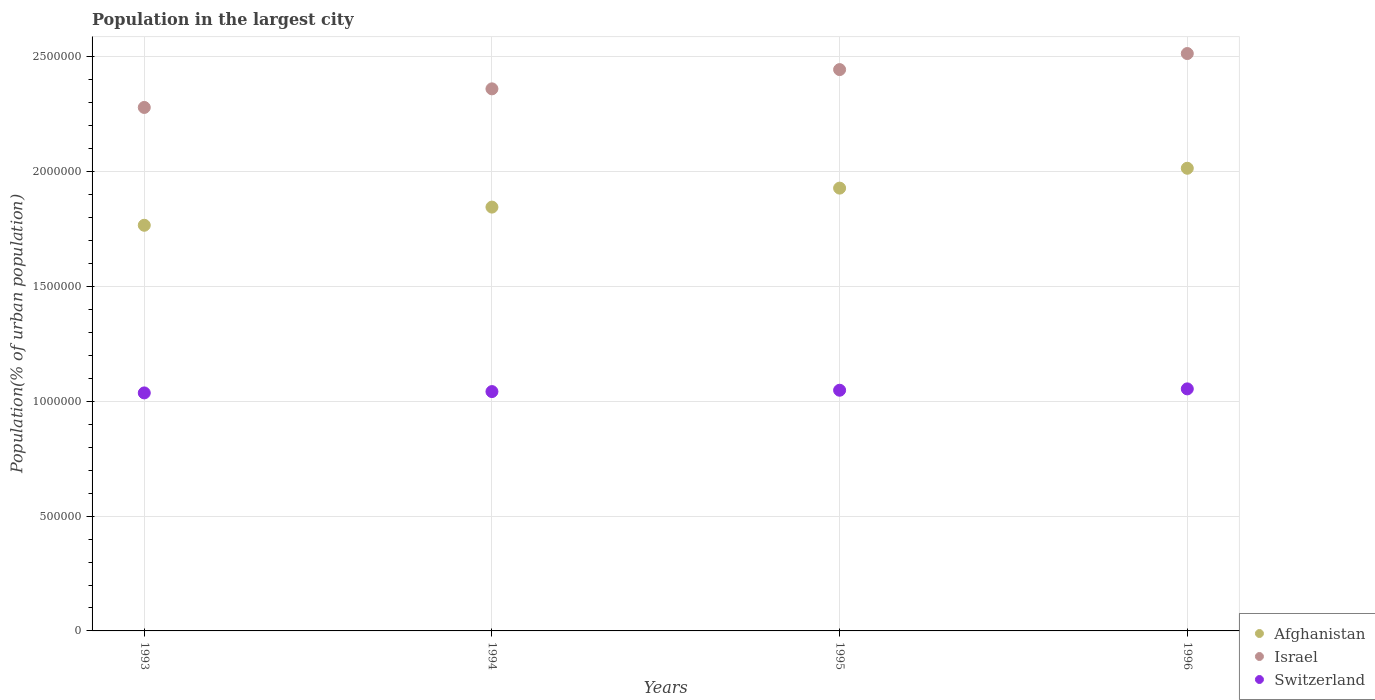Is the number of dotlines equal to the number of legend labels?
Offer a terse response. Yes. What is the population in the largest city in Switzerland in 1994?
Give a very brief answer. 1.04e+06. Across all years, what is the maximum population in the largest city in Afghanistan?
Provide a short and direct response. 2.02e+06. Across all years, what is the minimum population in the largest city in Afghanistan?
Make the answer very short. 1.77e+06. What is the total population in the largest city in Israel in the graph?
Ensure brevity in your answer.  9.60e+06. What is the difference between the population in the largest city in Switzerland in 1995 and that in 1996?
Provide a short and direct response. -5895. What is the difference between the population in the largest city in Switzerland in 1993 and the population in the largest city in Afghanistan in 1996?
Offer a very short reply. -9.78e+05. What is the average population in the largest city in Switzerland per year?
Keep it short and to the point. 1.05e+06. In the year 1993, what is the difference between the population in the largest city in Afghanistan and population in the largest city in Switzerland?
Make the answer very short. 7.30e+05. In how many years, is the population in the largest city in Israel greater than 500000 %?
Make the answer very short. 4. What is the ratio of the population in the largest city in Israel in 1994 to that in 1996?
Your response must be concise. 0.94. Is the difference between the population in the largest city in Afghanistan in 1994 and 1995 greater than the difference between the population in the largest city in Switzerland in 1994 and 1995?
Ensure brevity in your answer.  No. What is the difference between the highest and the second highest population in the largest city in Israel?
Offer a terse response. 6.99e+04. What is the difference between the highest and the lowest population in the largest city in Afghanistan?
Your response must be concise. 2.48e+05. In how many years, is the population in the largest city in Switzerland greater than the average population in the largest city in Switzerland taken over all years?
Offer a terse response. 2. Is the sum of the population in the largest city in Israel in 1993 and 1994 greater than the maximum population in the largest city in Switzerland across all years?
Keep it short and to the point. Yes. Is it the case that in every year, the sum of the population in the largest city in Afghanistan and population in the largest city in Switzerland  is greater than the population in the largest city in Israel?
Ensure brevity in your answer.  Yes. Does the population in the largest city in Switzerland monotonically increase over the years?
Your answer should be compact. Yes. Is the population in the largest city in Switzerland strictly greater than the population in the largest city in Afghanistan over the years?
Your response must be concise. No. Is the population in the largest city in Afghanistan strictly less than the population in the largest city in Israel over the years?
Provide a short and direct response. Yes. How many years are there in the graph?
Provide a short and direct response. 4. Does the graph contain grids?
Provide a succinct answer. Yes. Where does the legend appear in the graph?
Make the answer very short. Bottom right. How many legend labels are there?
Make the answer very short. 3. What is the title of the graph?
Provide a succinct answer. Population in the largest city. Does "Paraguay" appear as one of the legend labels in the graph?
Your response must be concise. No. What is the label or title of the Y-axis?
Your answer should be compact. Population(% of urban population). What is the Population(% of urban population) of Afghanistan in 1993?
Keep it short and to the point. 1.77e+06. What is the Population(% of urban population) in Israel in 1993?
Keep it short and to the point. 2.28e+06. What is the Population(% of urban population) in Switzerland in 1993?
Provide a succinct answer. 1.04e+06. What is the Population(% of urban population) in Afghanistan in 1994?
Your answer should be compact. 1.85e+06. What is the Population(% of urban population) of Israel in 1994?
Provide a succinct answer. 2.36e+06. What is the Population(% of urban population) of Switzerland in 1994?
Provide a succinct answer. 1.04e+06. What is the Population(% of urban population) in Afghanistan in 1995?
Give a very brief answer. 1.93e+06. What is the Population(% of urban population) of Israel in 1995?
Your answer should be compact. 2.44e+06. What is the Population(% of urban population) of Switzerland in 1995?
Your response must be concise. 1.05e+06. What is the Population(% of urban population) of Afghanistan in 1996?
Your answer should be very brief. 2.02e+06. What is the Population(% of urban population) of Israel in 1996?
Give a very brief answer. 2.51e+06. What is the Population(% of urban population) of Switzerland in 1996?
Your answer should be very brief. 1.05e+06. Across all years, what is the maximum Population(% of urban population) of Afghanistan?
Your answer should be very brief. 2.02e+06. Across all years, what is the maximum Population(% of urban population) in Israel?
Offer a terse response. 2.51e+06. Across all years, what is the maximum Population(% of urban population) of Switzerland?
Your response must be concise. 1.05e+06. Across all years, what is the minimum Population(% of urban population) in Afghanistan?
Make the answer very short. 1.77e+06. Across all years, what is the minimum Population(% of urban population) of Israel?
Keep it short and to the point. 2.28e+06. Across all years, what is the minimum Population(% of urban population) in Switzerland?
Offer a very short reply. 1.04e+06. What is the total Population(% of urban population) of Afghanistan in the graph?
Provide a short and direct response. 7.56e+06. What is the total Population(% of urban population) in Israel in the graph?
Provide a short and direct response. 9.60e+06. What is the total Population(% of urban population) of Switzerland in the graph?
Ensure brevity in your answer.  4.18e+06. What is the difference between the Population(% of urban population) of Afghanistan in 1993 and that in 1994?
Offer a terse response. -7.91e+04. What is the difference between the Population(% of urban population) of Israel in 1993 and that in 1994?
Provide a short and direct response. -8.10e+04. What is the difference between the Population(% of urban population) of Switzerland in 1993 and that in 1994?
Ensure brevity in your answer.  -5821. What is the difference between the Population(% of urban population) of Afghanistan in 1993 and that in 1995?
Your response must be concise. -1.62e+05. What is the difference between the Population(% of urban population) in Israel in 1993 and that in 1995?
Give a very brief answer. -1.65e+05. What is the difference between the Population(% of urban population) of Switzerland in 1993 and that in 1995?
Provide a short and direct response. -1.17e+04. What is the difference between the Population(% of urban population) in Afghanistan in 1993 and that in 1996?
Ensure brevity in your answer.  -2.48e+05. What is the difference between the Population(% of urban population) of Israel in 1993 and that in 1996?
Your answer should be very brief. -2.35e+05. What is the difference between the Population(% of urban population) in Switzerland in 1993 and that in 1996?
Provide a succinct answer. -1.76e+04. What is the difference between the Population(% of urban population) in Afghanistan in 1994 and that in 1995?
Ensure brevity in your answer.  -8.27e+04. What is the difference between the Population(% of urban population) of Israel in 1994 and that in 1995?
Provide a short and direct response. -8.39e+04. What is the difference between the Population(% of urban population) of Switzerland in 1994 and that in 1995?
Provide a succinct answer. -5854. What is the difference between the Population(% of urban population) of Afghanistan in 1994 and that in 1996?
Offer a very short reply. -1.69e+05. What is the difference between the Population(% of urban population) of Israel in 1994 and that in 1996?
Your response must be concise. -1.54e+05. What is the difference between the Population(% of urban population) in Switzerland in 1994 and that in 1996?
Your response must be concise. -1.17e+04. What is the difference between the Population(% of urban population) of Afghanistan in 1995 and that in 1996?
Offer a terse response. -8.65e+04. What is the difference between the Population(% of urban population) in Israel in 1995 and that in 1996?
Your answer should be very brief. -6.99e+04. What is the difference between the Population(% of urban population) of Switzerland in 1995 and that in 1996?
Give a very brief answer. -5895. What is the difference between the Population(% of urban population) of Afghanistan in 1993 and the Population(% of urban population) of Israel in 1994?
Make the answer very short. -5.94e+05. What is the difference between the Population(% of urban population) in Afghanistan in 1993 and the Population(% of urban population) in Switzerland in 1994?
Your response must be concise. 7.24e+05. What is the difference between the Population(% of urban population) of Israel in 1993 and the Population(% of urban population) of Switzerland in 1994?
Offer a very short reply. 1.24e+06. What is the difference between the Population(% of urban population) in Afghanistan in 1993 and the Population(% of urban population) in Israel in 1995?
Keep it short and to the point. -6.78e+05. What is the difference between the Population(% of urban population) of Afghanistan in 1993 and the Population(% of urban population) of Switzerland in 1995?
Offer a terse response. 7.19e+05. What is the difference between the Population(% of urban population) in Israel in 1993 and the Population(% of urban population) in Switzerland in 1995?
Give a very brief answer. 1.23e+06. What is the difference between the Population(% of urban population) in Afghanistan in 1993 and the Population(% of urban population) in Israel in 1996?
Your response must be concise. -7.48e+05. What is the difference between the Population(% of urban population) of Afghanistan in 1993 and the Population(% of urban population) of Switzerland in 1996?
Provide a short and direct response. 7.13e+05. What is the difference between the Population(% of urban population) in Israel in 1993 and the Population(% of urban population) in Switzerland in 1996?
Offer a very short reply. 1.23e+06. What is the difference between the Population(% of urban population) in Afghanistan in 1994 and the Population(% of urban population) in Israel in 1995?
Keep it short and to the point. -5.99e+05. What is the difference between the Population(% of urban population) of Afghanistan in 1994 and the Population(% of urban population) of Switzerland in 1995?
Give a very brief answer. 7.98e+05. What is the difference between the Population(% of urban population) of Israel in 1994 and the Population(% of urban population) of Switzerland in 1995?
Provide a succinct answer. 1.31e+06. What is the difference between the Population(% of urban population) in Afghanistan in 1994 and the Population(% of urban population) in Israel in 1996?
Give a very brief answer. -6.69e+05. What is the difference between the Population(% of urban population) in Afghanistan in 1994 and the Population(% of urban population) in Switzerland in 1996?
Give a very brief answer. 7.92e+05. What is the difference between the Population(% of urban population) of Israel in 1994 and the Population(% of urban population) of Switzerland in 1996?
Offer a very short reply. 1.31e+06. What is the difference between the Population(% of urban population) in Afghanistan in 1995 and the Population(% of urban population) in Israel in 1996?
Your answer should be very brief. -5.86e+05. What is the difference between the Population(% of urban population) of Afghanistan in 1995 and the Population(% of urban population) of Switzerland in 1996?
Provide a short and direct response. 8.74e+05. What is the difference between the Population(% of urban population) of Israel in 1995 and the Population(% of urban population) of Switzerland in 1996?
Provide a short and direct response. 1.39e+06. What is the average Population(% of urban population) of Afghanistan per year?
Provide a short and direct response. 1.89e+06. What is the average Population(% of urban population) in Israel per year?
Your response must be concise. 2.40e+06. What is the average Population(% of urban population) in Switzerland per year?
Provide a succinct answer. 1.05e+06. In the year 1993, what is the difference between the Population(% of urban population) of Afghanistan and Population(% of urban population) of Israel?
Provide a succinct answer. -5.13e+05. In the year 1993, what is the difference between the Population(% of urban population) of Afghanistan and Population(% of urban population) of Switzerland?
Make the answer very short. 7.30e+05. In the year 1993, what is the difference between the Population(% of urban population) of Israel and Population(% of urban population) of Switzerland?
Your answer should be very brief. 1.24e+06. In the year 1994, what is the difference between the Population(% of urban population) of Afghanistan and Population(% of urban population) of Israel?
Offer a very short reply. -5.15e+05. In the year 1994, what is the difference between the Population(% of urban population) of Afghanistan and Population(% of urban population) of Switzerland?
Offer a terse response. 8.04e+05. In the year 1994, what is the difference between the Population(% of urban population) of Israel and Population(% of urban population) of Switzerland?
Keep it short and to the point. 1.32e+06. In the year 1995, what is the difference between the Population(% of urban population) in Afghanistan and Population(% of urban population) in Israel?
Your answer should be very brief. -5.16e+05. In the year 1995, what is the difference between the Population(% of urban population) in Afghanistan and Population(% of urban population) in Switzerland?
Provide a succinct answer. 8.80e+05. In the year 1995, what is the difference between the Population(% of urban population) of Israel and Population(% of urban population) of Switzerland?
Provide a short and direct response. 1.40e+06. In the year 1996, what is the difference between the Population(% of urban population) of Afghanistan and Population(% of urban population) of Israel?
Keep it short and to the point. -5.00e+05. In the year 1996, what is the difference between the Population(% of urban population) in Afghanistan and Population(% of urban population) in Switzerland?
Provide a short and direct response. 9.61e+05. In the year 1996, what is the difference between the Population(% of urban population) in Israel and Population(% of urban population) in Switzerland?
Keep it short and to the point. 1.46e+06. What is the ratio of the Population(% of urban population) in Afghanistan in 1993 to that in 1994?
Make the answer very short. 0.96. What is the ratio of the Population(% of urban population) of Israel in 1993 to that in 1994?
Your answer should be compact. 0.97. What is the ratio of the Population(% of urban population) in Switzerland in 1993 to that in 1994?
Offer a very short reply. 0.99. What is the ratio of the Population(% of urban population) in Afghanistan in 1993 to that in 1995?
Ensure brevity in your answer.  0.92. What is the ratio of the Population(% of urban population) in Israel in 1993 to that in 1995?
Offer a terse response. 0.93. What is the ratio of the Population(% of urban population) in Switzerland in 1993 to that in 1995?
Give a very brief answer. 0.99. What is the ratio of the Population(% of urban population) of Afghanistan in 1993 to that in 1996?
Offer a very short reply. 0.88. What is the ratio of the Population(% of urban population) in Israel in 1993 to that in 1996?
Your answer should be compact. 0.91. What is the ratio of the Population(% of urban population) of Switzerland in 1993 to that in 1996?
Ensure brevity in your answer.  0.98. What is the ratio of the Population(% of urban population) in Afghanistan in 1994 to that in 1995?
Make the answer very short. 0.96. What is the ratio of the Population(% of urban population) of Israel in 1994 to that in 1995?
Your answer should be very brief. 0.97. What is the ratio of the Population(% of urban population) of Afghanistan in 1994 to that in 1996?
Your response must be concise. 0.92. What is the ratio of the Population(% of urban population) of Israel in 1994 to that in 1996?
Your answer should be very brief. 0.94. What is the ratio of the Population(% of urban population) in Switzerland in 1994 to that in 1996?
Give a very brief answer. 0.99. What is the ratio of the Population(% of urban population) of Afghanistan in 1995 to that in 1996?
Ensure brevity in your answer.  0.96. What is the ratio of the Population(% of urban population) in Israel in 1995 to that in 1996?
Provide a short and direct response. 0.97. What is the ratio of the Population(% of urban population) of Switzerland in 1995 to that in 1996?
Your answer should be compact. 0.99. What is the difference between the highest and the second highest Population(% of urban population) in Afghanistan?
Ensure brevity in your answer.  8.65e+04. What is the difference between the highest and the second highest Population(% of urban population) in Israel?
Keep it short and to the point. 6.99e+04. What is the difference between the highest and the second highest Population(% of urban population) of Switzerland?
Provide a succinct answer. 5895. What is the difference between the highest and the lowest Population(% of urban population) in Afghanistan?
Your response must be concise. 2.48e+05. What is the difference between the highest and the lowest Population(% of urban population) in Israel?
Your answer should be very brief. 2.35e+05. What is the difference between the highest and the lowest Population(% of urban population) in Switzerland?
Offer a terse response. 1.76e+04. 